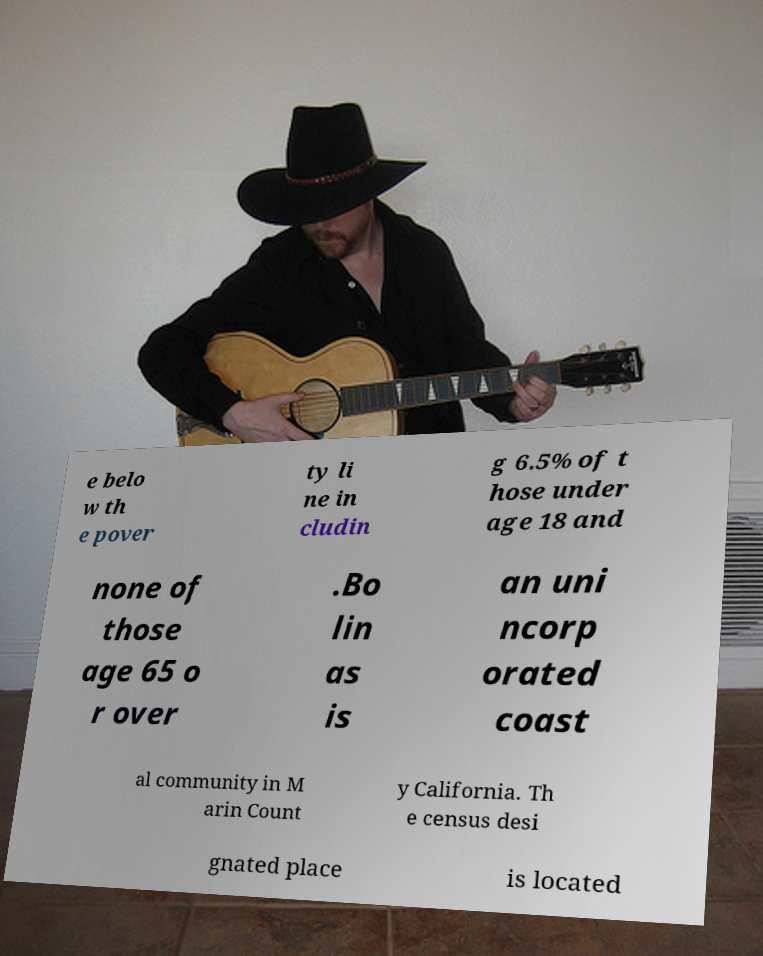What messages or text are displayed in this image? I need them in a readable, typed format. e belo w th e pover ty li ne in cludin g 6.5% of t hose under age 18 and none of those age 65 o r over .Bo lin as is an uni ncorp orated coast al community in M arin Count y California. Th e census desi gnated place is located 